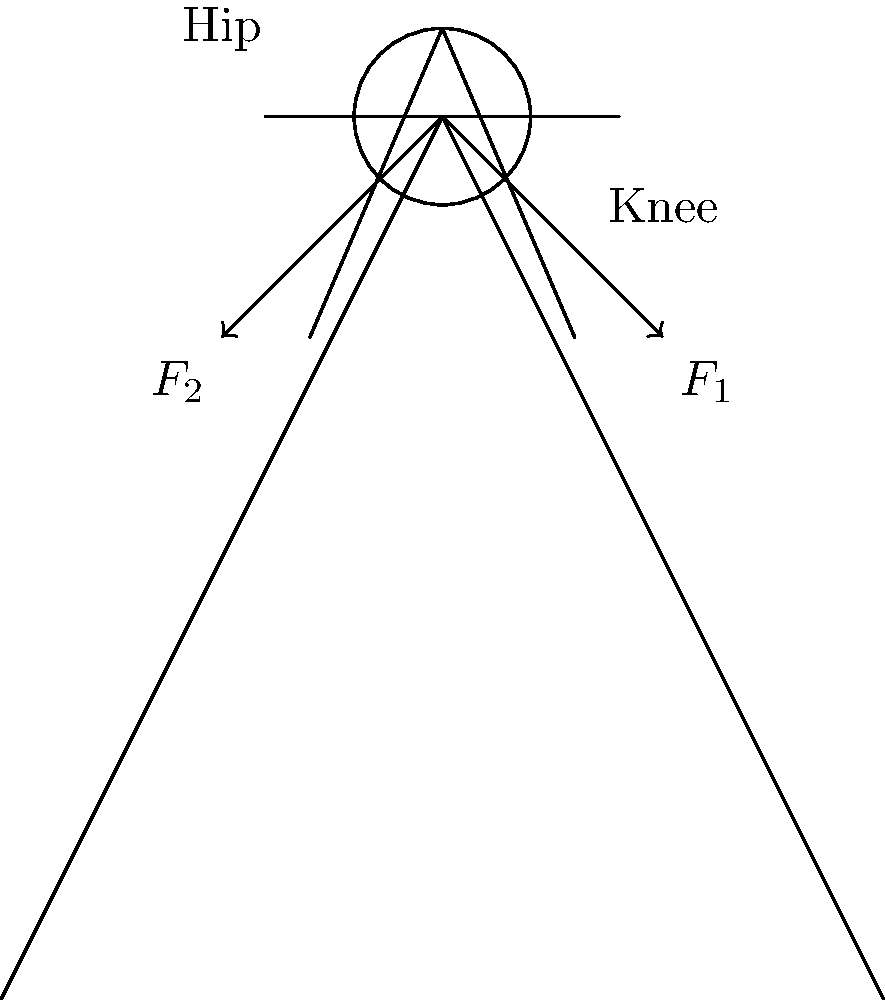In a crucial play during the Big Ten championship game, a running back is tackled simultaneously by two defenders. The impact forces on the player's knee and hip joints are represented by $F_1$ and $F_2$ in the stick figure diagram. If $F_1 = 1500$ N and $F_2 = 1200$ N, what is the magnitude of the resultant force on the player's center of mass, assuming the forces act at a 90-degree angle to each other? To solve this problem, we'll use the following steps:

1) Recognize that the two forces ($F_1$ and $F_2$) are perpendicular to each other, forming a right triangle.

2) Recall the Pythagorean theorem for right triangles: $c^2 = a^2 + b^2$, where $c$ is the hypotenuse and $a$ and $b$ are the other two sides.

3) In this case, $F_1$ and $F_2$ represent the sides of the triangle, and the resultant force ($F_R$) is the hypotenuse.

4) Apply the Pythagorean theorem:
   $F_R^2 = F_1^2 + F_2^2$

5) Substitute the given values:
   $F_R^2 = 1500^2 + 1200^2$

6) Calculate:
   $F_R^2 = 2,250,000 + 1,440,000 = 3,690,000$

7) Take the square root of both sides:
   $F_R = \sqrt{3,690,000} \approx 1921.46$ N

8) Round to a reasonable number of significant figures (3 in this case):
   $F_R \approx 1920$ N
Answer: 1920 N 